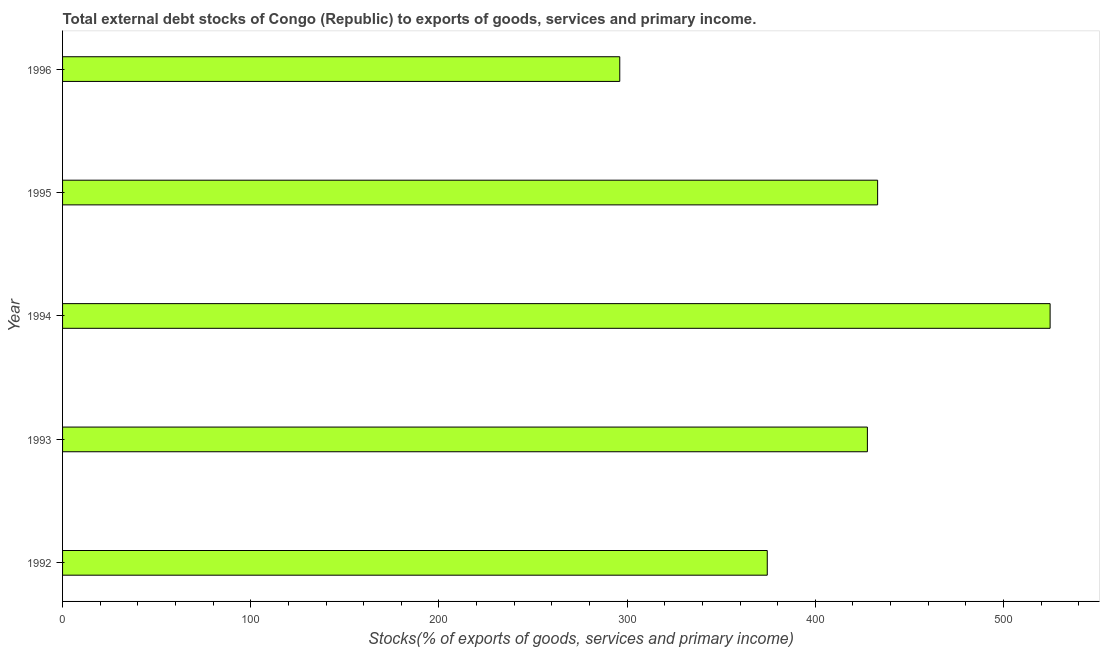Does the graph contain grids?
Offer a terse response. No. What is the title of the graph?
Keep it short and to the point. Total external debt stocks of Congo (Republic) to exports of goods, services and primary income. What is the label or title of the X-axis?
Your answer should be very brief. Stocks(% of exports of goods, services and primary income). What is the label or title of the Y-axis?
Keep it short and to the point. Year. What is the external debt stocks in 1995?
Offer a terse response. 433.09. Across all years, what is the maximum external debt stocks?
Offer a very short reply. 524.75. Across all years, what is the minimum external debt stocks?
Offer a terse response. 296.07. In which year was the external debt stocks maximum?
Ensure brevity in your answer.  1994. What is the sum of the external debt stocks?
Ensure brevity in your answer.  2056.02. What is the difference between the external debt stocks in 1993 and 1996?
Offer a terse response. 131.58. What is the average external debt stocks per year?
Provide a short and direct response. 411.2. What is the median external debt stocks?
Provide a succinct answer. 427.65. Do a majority of the years between 1995 and 1994 (inclusive) have external debt stocks greater than 180 %?
Your answer should be very brief. No. What is the ratio of the external debt stocks in 1995 to that in 1996?
Provide a succinct answer. 1.46. What is the difference between the highest and the second highest external debt stocks?
Keep it short and to the point. 91.65. What is the difference between the highest and the lowest external debt stocks?
Make the answer very short. 228.68. In how many years, is the external debt stocks greater than the average external debt stocks taken over all years?
Provide a succinct answer. 3. Are all the bars in the graph horizontal?
Ensure brevity in your answer.  Yes. How many years are there in the graph?
Make the answer very short. 5. What is the Stocks(% of exports of goods, services and primary income) in 1992?
Offer a very short reply. 374.45. What is the Stocks(% of exports of goods, services and primary income) in 1993?
Provide a succinct answer. 427.65. What is the Stocks(% of exports of goods, services and primary income) of 1994?
Provide a succinct answer. 524.75. What is the Stocks(% of exports of goods, services and primary income) of 1995?
Your response must be concise. 433.09. What is the Stocks(% of exports of goods, services and primary income) in 1996?
Give a very brief answer. 296.07. What is the difference between the Stocks(% of exports of goods, services and primary income) in 1992 and 1993?
Provide a short and direct response. -53.2. What is the difference between the Stocks(% of exports of goods, services and primary income) in 1992 and 1994?
Provide a succinct answer. -150.29. What is the difference between the Stocks(% of exports of goods, services and primary income) in 1992 and 1995?
Offer a very short reply. -58.64. What is the difference between the Stocks(% of exports of goods, services and primary income) in 1992 and 1996?
Offer a very short reply. 78.38. What is the difference between the Stocks(% of exports of goods, services and primary income) in 1993 and 1994?
Your answer should be very brief. -97.1. What is the difference between the Stocks(% of exports of goods, services and primary income) in 1993 and 1995?
Your response must be concise. -5.44. What is the difference between the Stocks(% of exports of goods, services and primary income) in 1993 and 1996?
Give a very brief answer. 131.58. What is the difference between the Stocks(% of exports of goods, services and primary income) in 1994 and 1995?
Your answer should be very brief. 91.65. What is the difference between the Stocks(% of exports of goods, services and primary income) in 1994 and 1996?
Keep it short and to the point. 228.68. What is the difference between the Stocks(% of exports of goods, services and primary income) in 1995 and 1996?
Your answer should be very brief. 137.02. What is the ratio of the Stocks(% of exports of goods, services and primary income) in 1992 to that in 1993?
Your response must be concise. 0.88. What is the ratio of the Stocks(% of exports of goods, services and primary income) in 1992 to that in 1994?
Give a very brief answer. 0.71. What is the ratio of the Stocks(% of exports of goods, services and primary income) in 1992 to that in 1995?
Ensure brevity in your answer.  0.86. What is the ratio of the Stocks(% of exports of goods, services and primary income) in 1992 to that in 1996?
Give a very brief answer. 1.26. What is the ratio of the Stocks(% of exports of goods, services and primary income) in 1993 to that in 1994?
Provide a short and direct response. 0.81. What is the ratio of the Stocks(% of exports of goods, services and primary income) in 1993 to that in 1995?
Keep it short and to the point. 0.99. What is the ratio of the Stocks(% of exports of goods, services and primary income) in 1993 to that in 1996?
Provide a short and direct response. 1.44. What is the ratio of the Stocks(% of exports of goods, services and primary income) in 1994 to that in 1995?
Provide a short and direct response. 1.21. What is the ratio of the Stocks(% of exports of goods, services and primary income) in 1994 to that in 1996?
Your answer should be compact. 1.77. What is the ratio of the Stocks(% of exports of goods, services and primary income) in 1995 to that in 1996?
Your response must be concise. 1.46. 